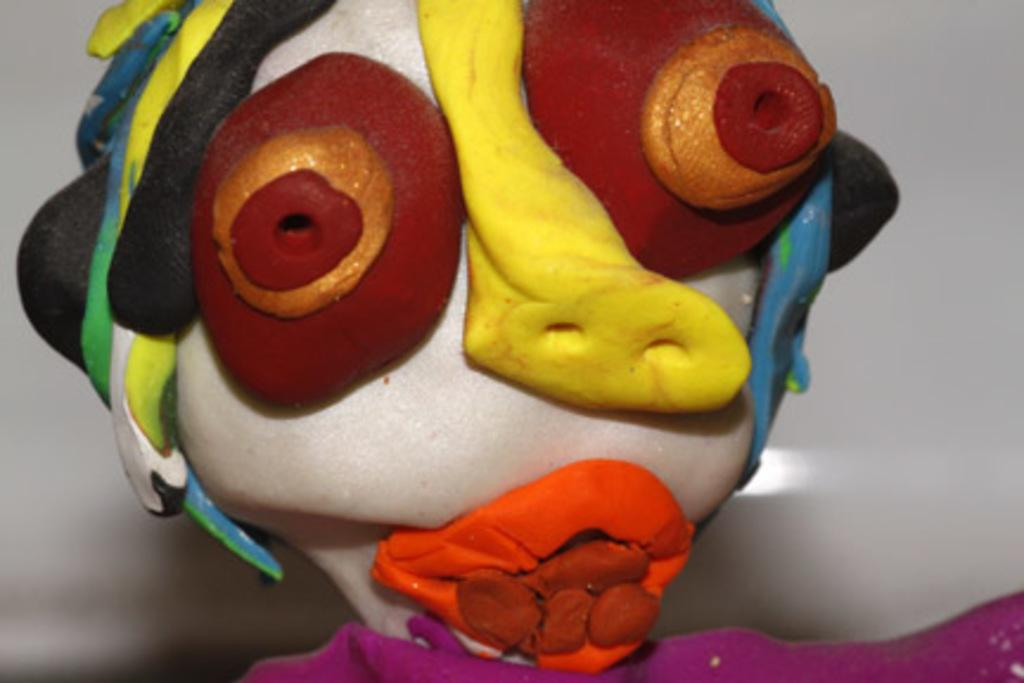What object can be seen in the image? There is a toy in the image. What color is the background of the image? The background of the image is white. What invention is being used by the toy in the image? There is no invention being used by the toy in the image, as the toy is not depicted as interacting with any specific device or technology. 